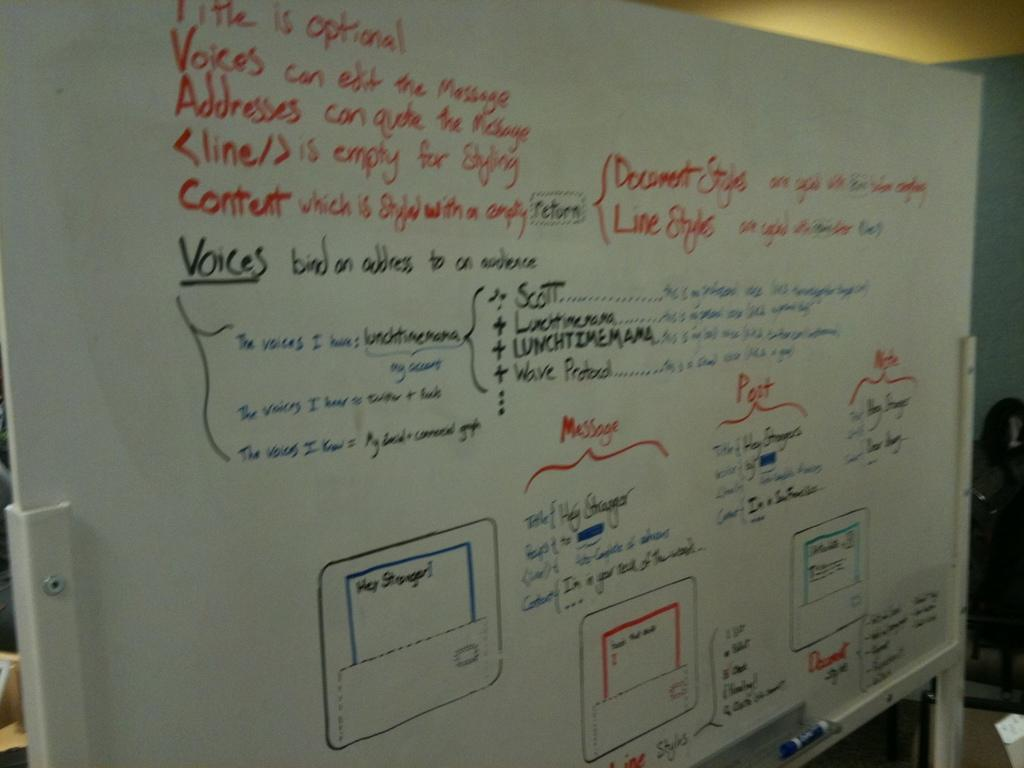<image>
Describe the image concisely. A large white dry erase board being used to convey messages. 